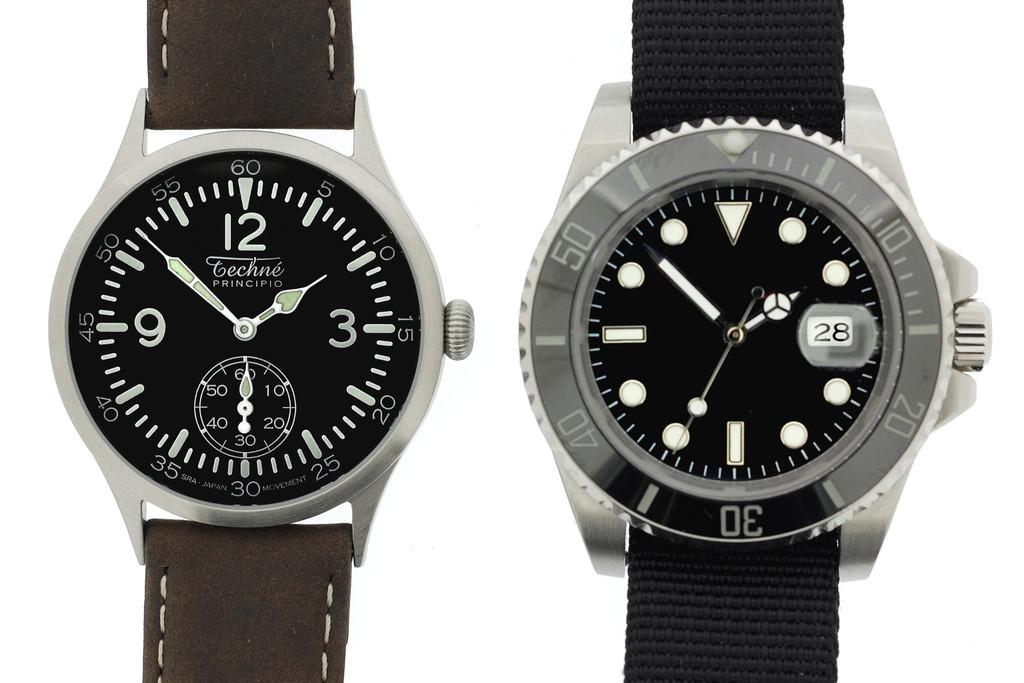<image>
Summarize the visual content of the image. Two watches are shown and the one on the right displays 28 in the seconds display. 